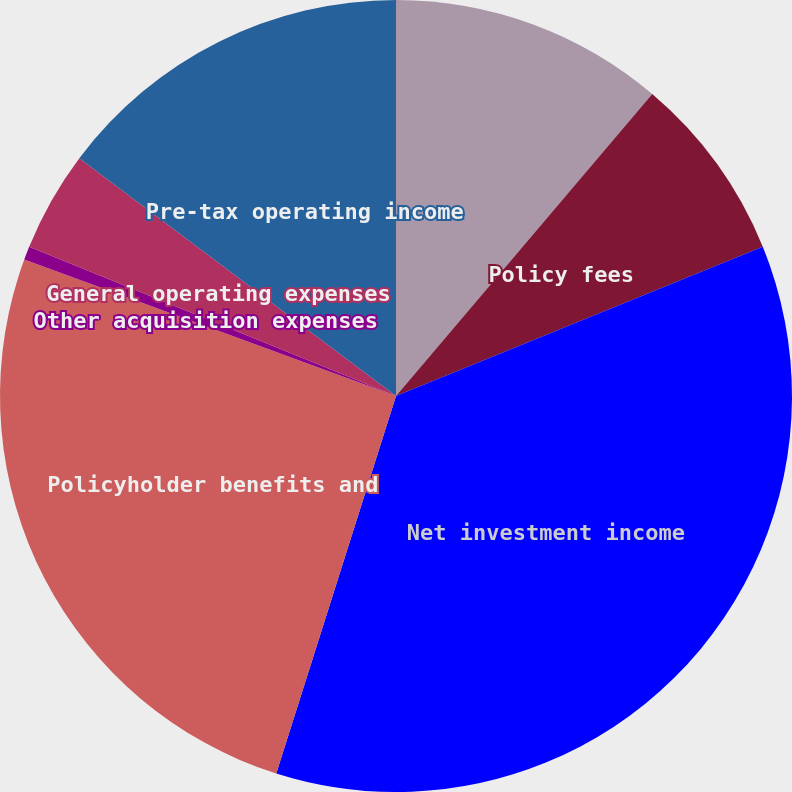Convert chart to OTSL. <chart><loc_0><loc_0><loc_500><loc_500><pie_chart><fcel>Premiums<fcel>Policy fees<fcel>Net investment income<fcel>Policyholder benefits and<fcel>Other acquisition expenses<fcel>General operating expenses<fcel>Pre-tax operating income<nl><fcel>11.2%<fcel>7.65%<fcel>36.04%<fcel>25.71%<fcel>0.55%<fcel>4.1%<fcel>14.75%<nl></chart> 